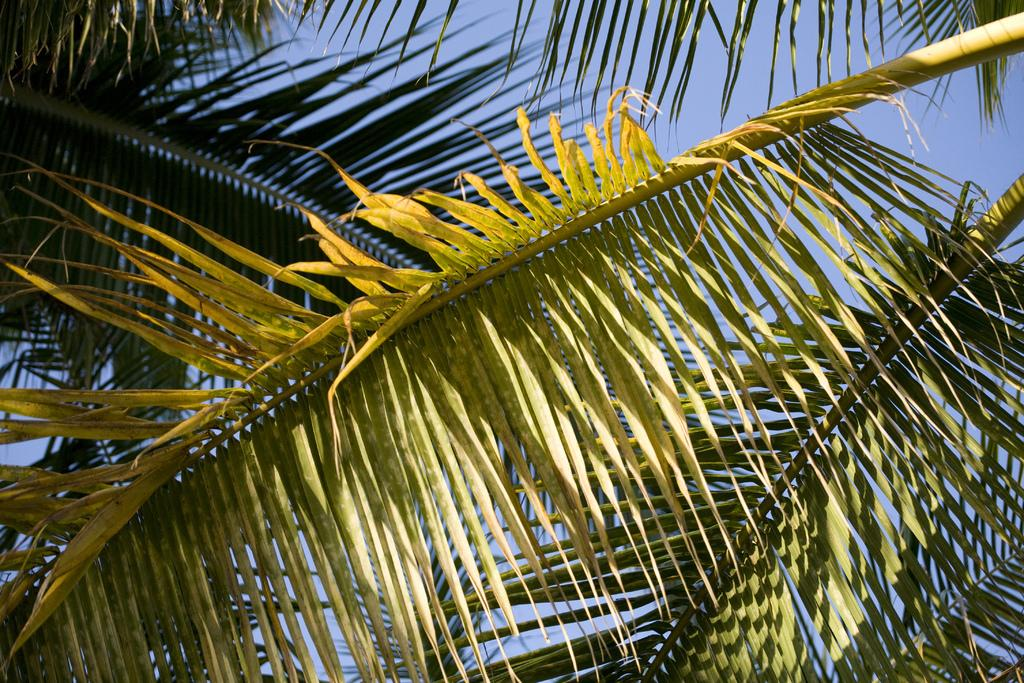What type of vegetation can be seen in the front of the image? There are leaves in the front of the image. How many people are leading the leaves in the image? There are no people present in the image, and the leaves are not being led by anyone. 